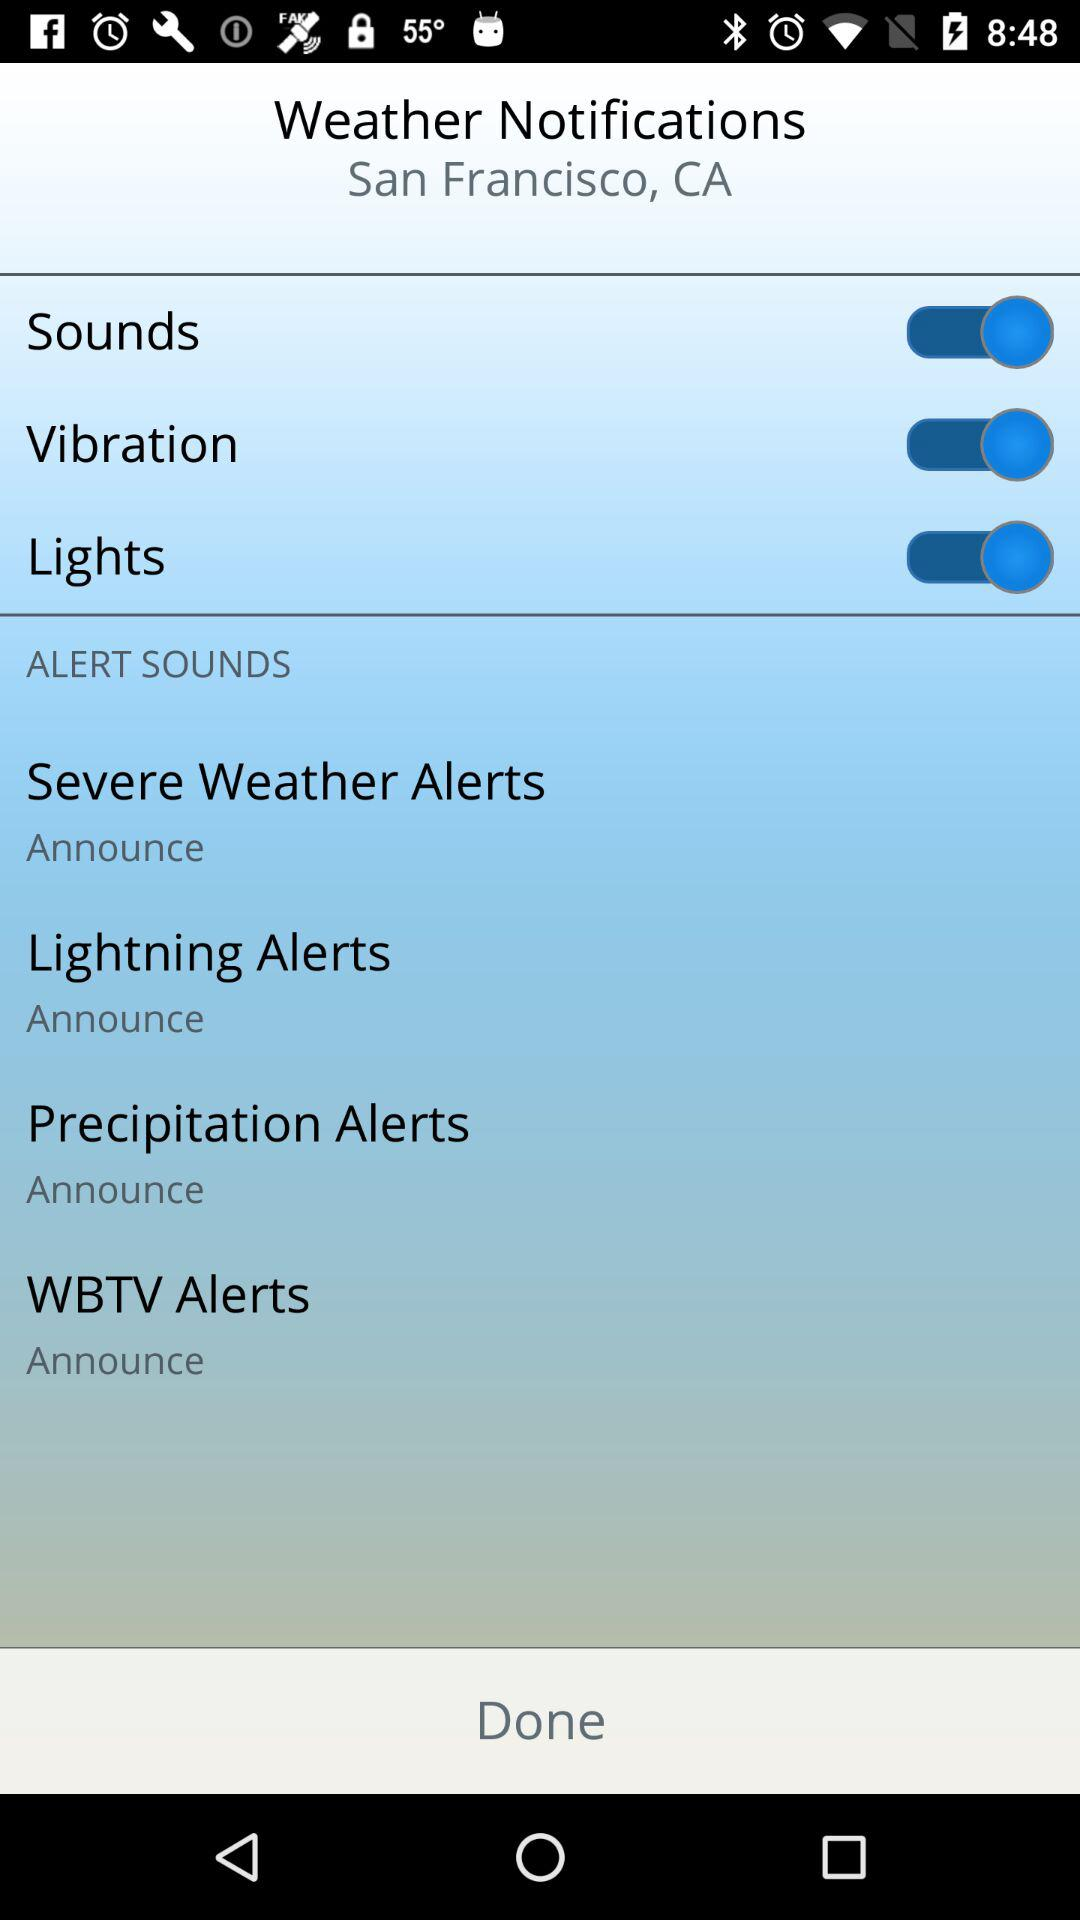How many alerts have an announce option?
Answer the question using a single word or phrase. 4 